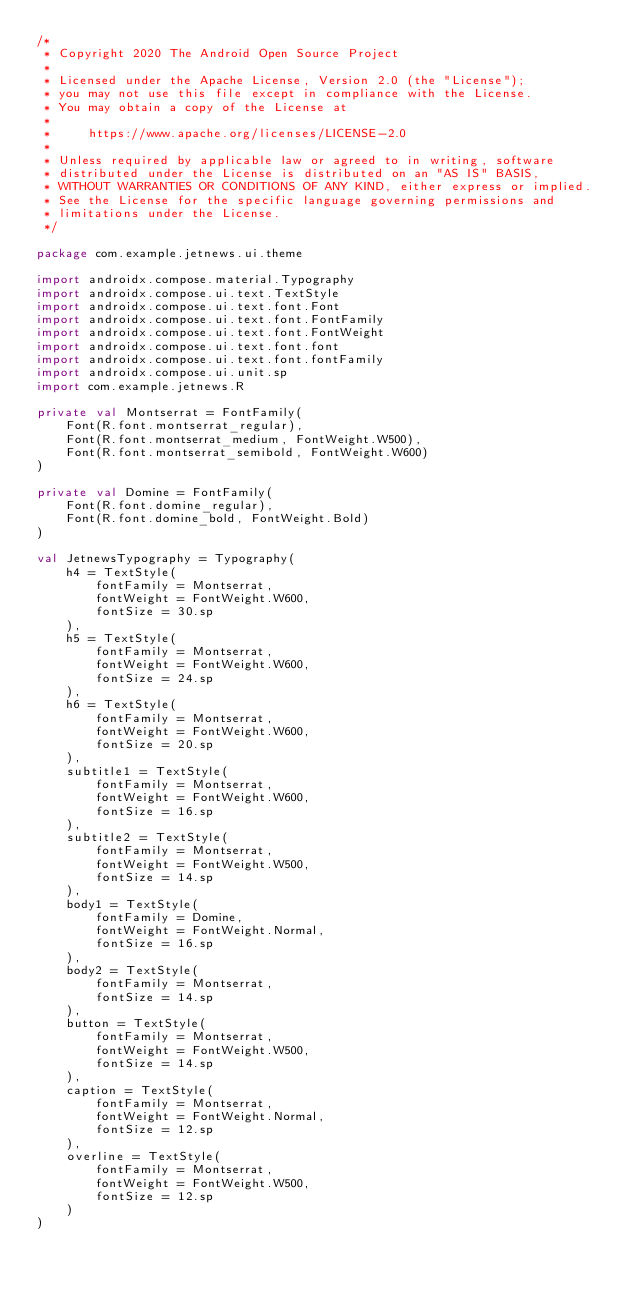Convert code to text. <code><loc_0><loc_0><loc_500><loc_500><_Kotlin_>/*
 * Copyright 2020 The Android Open Source Project
 *
 * Licensed under the Apache License, Version 2.0 (the "License");
 * you may not use this file except in compliance with the License.
 * You may obtain a copy of the License at
 *
 *     https://www.apache.org/licenses/LICENSE-2.0
 *
 * Unless required by applicable law or agreed to in writing, software
 * distributed under the License is distributed on an "AS IS" BASIS,
 * WITHOUT WARRANTIES OR CONDITIONS OF ANY KIND, either express or implied.
 * See the License for the specific language governing permissions and
 * limitations under the License.
 */

package com.example.jetnews.ui.theme

import androidx.compose.material.Typography
import androidx.compose.ui.text.TextStyle
import androidx.compose.ui.text.font.Font
import androidx.compose.ui.text.font.FontFamily
import androidx.compose.ui.text.font.FontWeight
import androidx.compose.ui.text.font.font
import androidx.compose.ui.text.font.fontFamily
import androidx.compose.ui.unit.sp
import com.example.jetnews.R

private val Montserrat = FontFamily(
    Font(R.font.montserrat_regular),
    Font(R.font.montserrat_medium, FontWeight.W500),
    Font(R.font.montserrat_semibold, FontWeight.W600)
)

private val Domine = FontFamily(
    Font(R.font.domine_regular),
    Font(R.font.domine_bold, FontWeight.Bold)
)

val JetnewsTypography = Typography(
    h4 = TextStyle(
        fontFamily = Montserrat,
        fontWeight = FontWeight.W600,
        fontSize = 30.sp
    ),
    h5 = TextStyle(
        fontFamily = Montserrat,
        fontWeight = FontWeight.W600,
        fontSize = 24.sp
    ),
    h6 = TextStyle(
        fontFamily = Montserrat,
        fontWeight = FontWeight.W600,
        fontSize = 20.sp
    ),
    subtitle1 = TextStyle(
        fontFamily = Montserrat,
        fontWeight = FontWeight.W600,
        fontSize = 16.sp
    ),
    subtitle2 = TextStyle(
        fontFamily = Montserrat,
        fontWeight = FontWeight.W500,
        fontSize = 14.sp
    ),
    body1 = TextStyle(
        fontFamily = Domine,
        fontWeight = FontWeight.Normal,
        fontSize = 16.sp
    ),
    body2 = TextStyle(
        fontFamily = Montserrat,
        fontSize = 14.sp
    ),
    button = TextStyle(
        fontFamily = Montserrat,
        fontWeight = FontWeight.W500,
        fontSize = 14.sp
    ),
    caption = TextStyle(
        fontFamily = Montserrat,
        fontWeight = FontWeight.Normal,
        fontSize = 12.sp
    ),
    overline = TextStyle(
        fontFamily = Montserrat,
        fontWeight = FontWeight.W500,
        fontSize = 12.sp
    )
)
</code> 